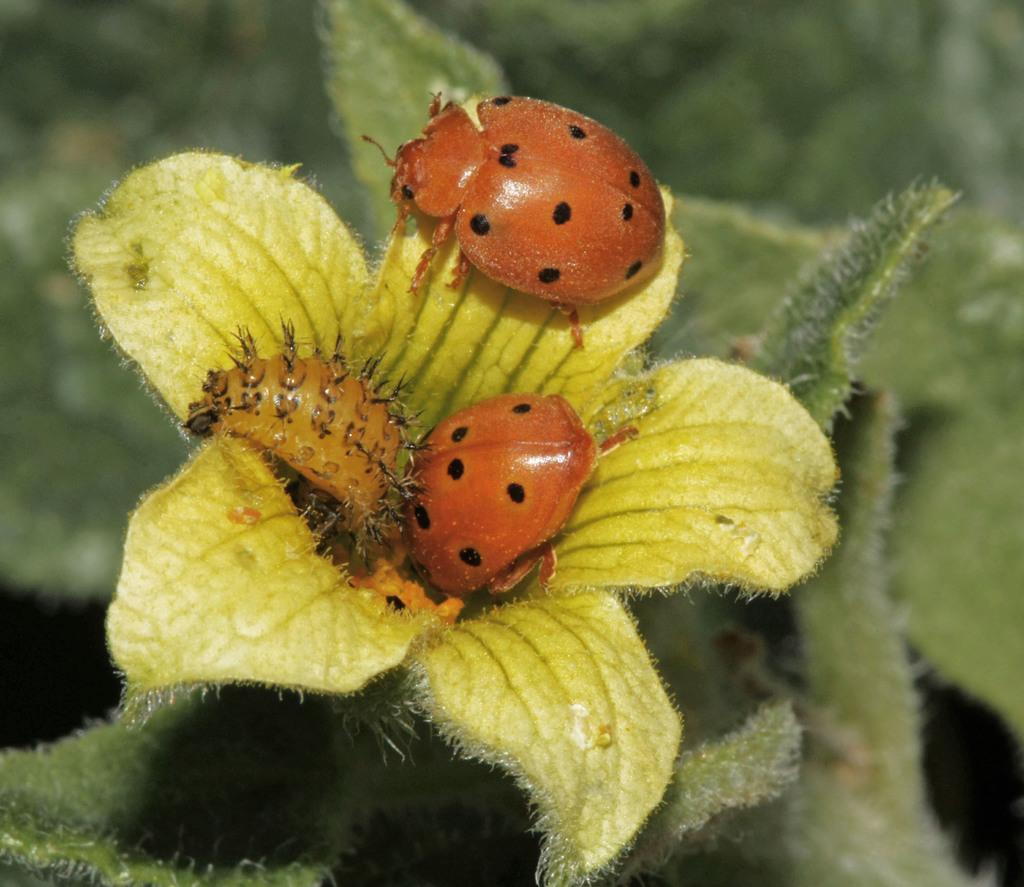Can you describe this image briefly? In the center of the image there are insects on the flower. At the bottom of the image there are leaves. 